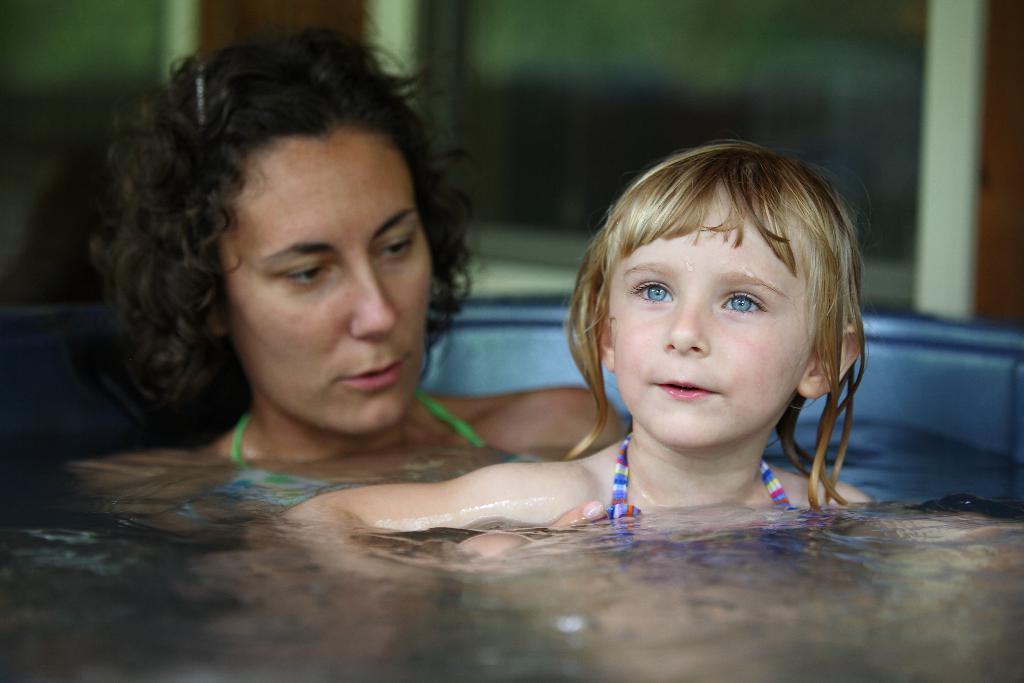Who is present in the image? There is a woman and a girl in the image. What are they doing in the image? Both the woman and the girl are in a bathtub. What is the woman doing in relation to the girl? The woman is looking at the girl. Can you describe the background of the image? The backdrop of the image is blurred. What type of curtain is hanging in the bathtub in the image? There is no curtain present in the bathtub or the image. Is the girl crying in the image? There is no indication in the image that the girl is crying. 